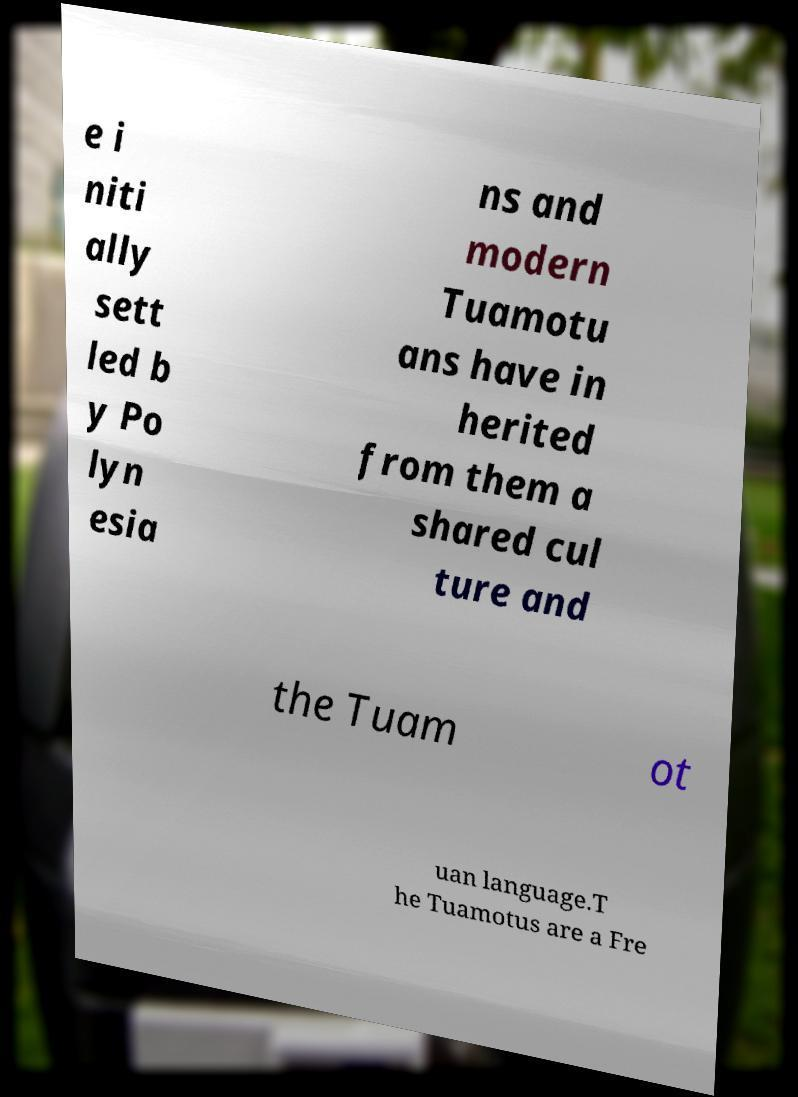Could you assist in decoding the text presented in this image and type it out clearly? e i niti ally sett led b y Po lyn esia ns and modern Tuamotu ans have in herited from them a shared cul ture and the Tuam ot uan language.T he Tuamotus are a Fre 